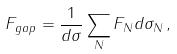<formula> <loc_0><loc_0><loc_500><loc_500>F _ { g a p } = \frac { 1 } { d \sigma } \sum _ { N } F _ { N } d \sigma _ { N } \, ,</formula> 